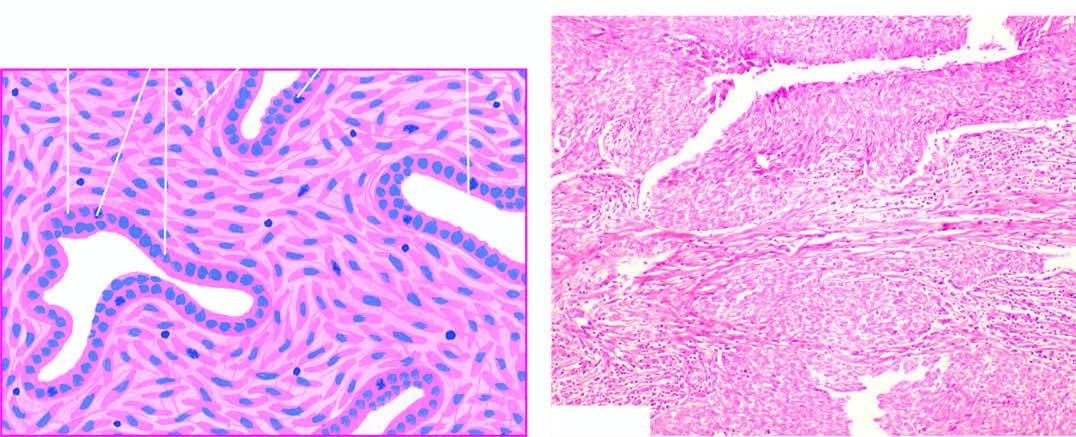what is composed of epithelial-like cells lining cleft-like spaces and gland-like structures?
Answer the question using a single word or phrase. Tumour 